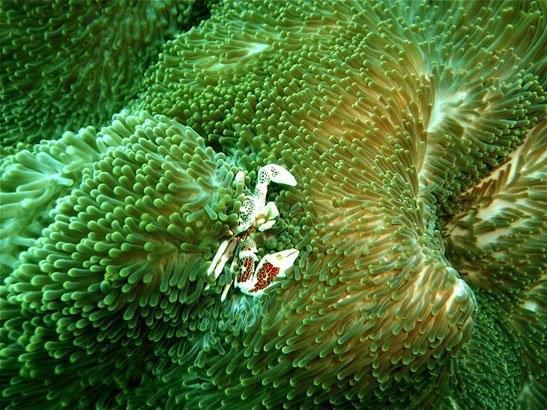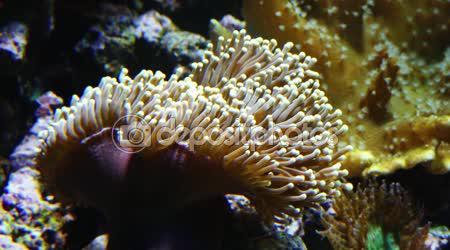The first image is the image on the left, the second image is the image on the right. For the images shown, is this caption "IN at least one image there is at least 10 circled yellow and brown corral  arms facing forward." true? Answer yes or no. No. The first image is the image on the left, the second image is the image on the right. Analyze the images presented: Is the assertion "One image shows a mass of flower-shaped anemone with flatter white centers surrounded by slender tendrils." valid? Answer yes or no. No. 